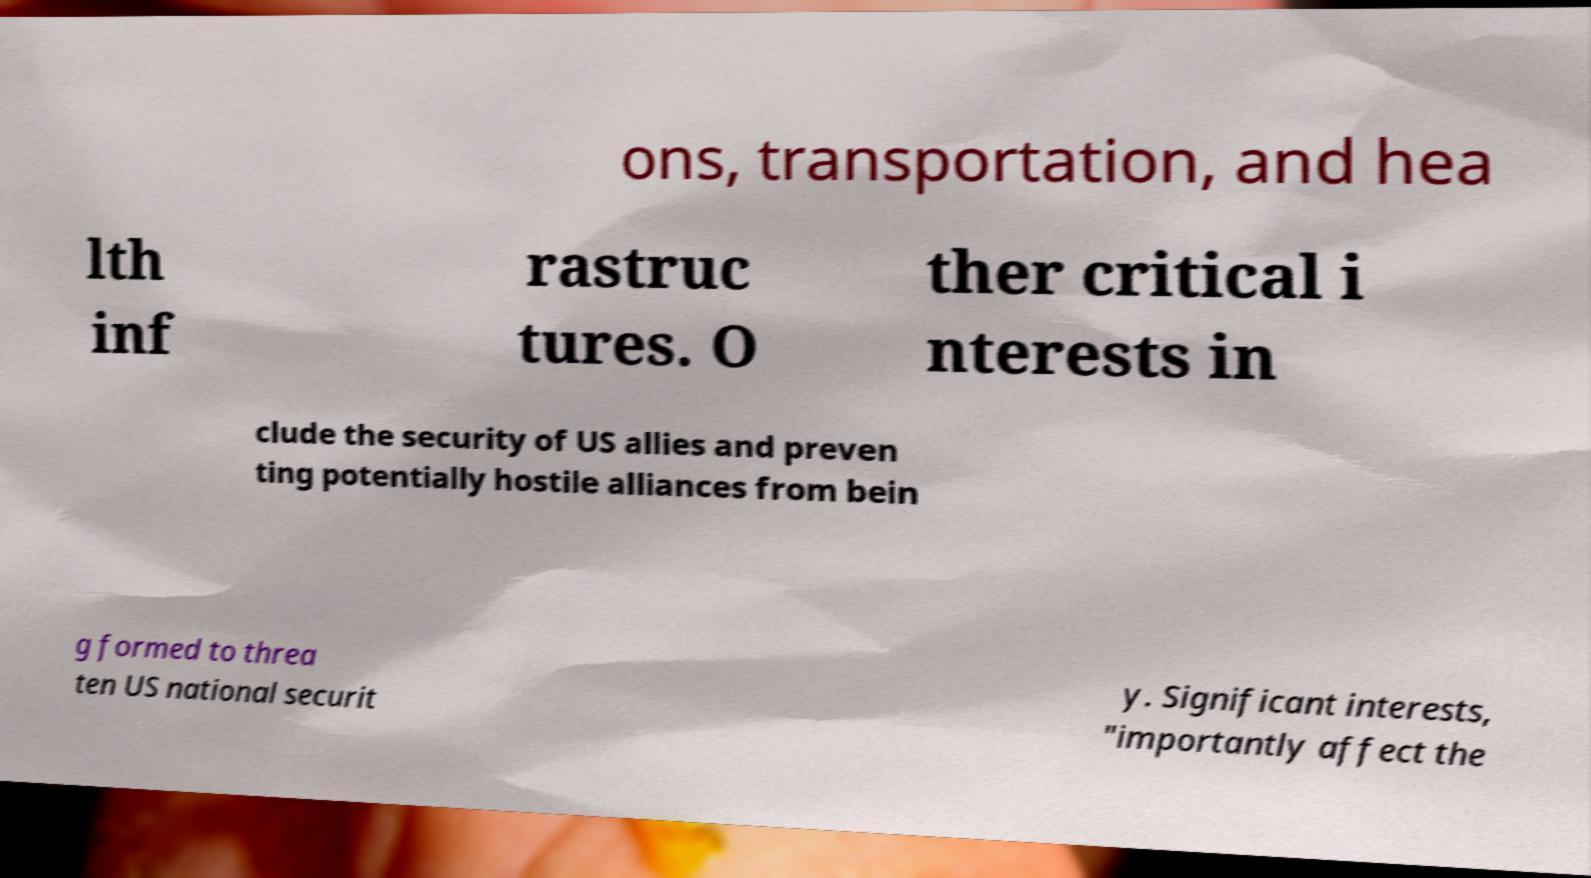What messages or text are displayed in this image? I need them in a readable, typed format. ons, transportation, and hea lth inf rastruc tures. O ther critical i nterests in clude the security of US allies and preven ting potentially hostile alliances from bein g formed to threa ten US national securit y. Significant interests, "importantly affect the 